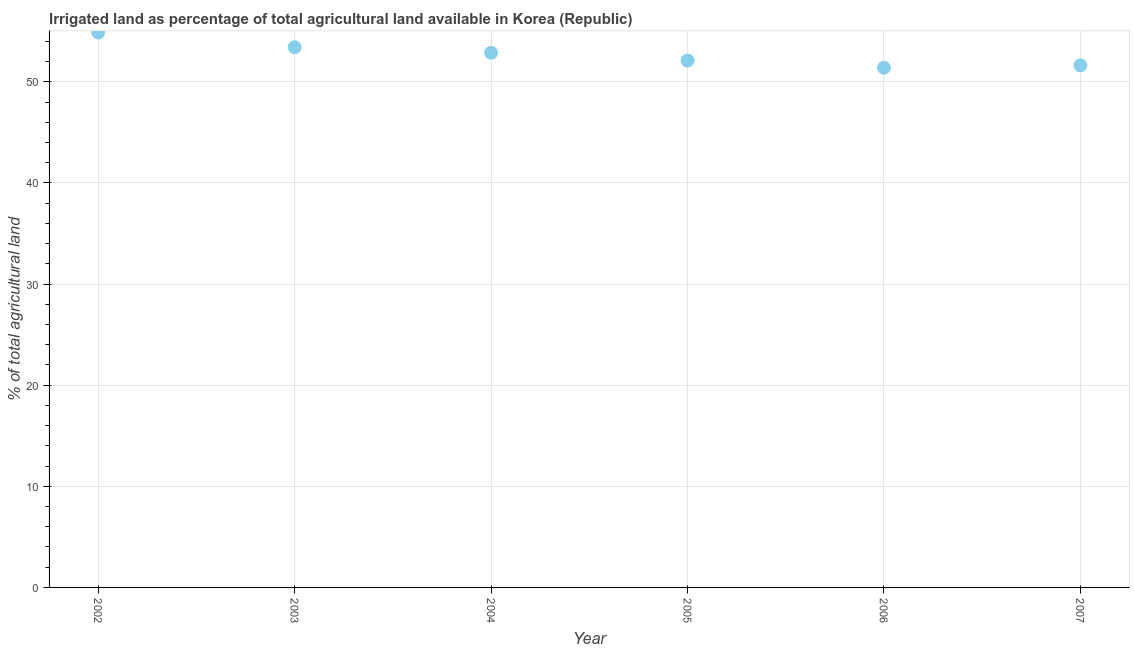What is the percentage of agricultural irrigated land in 2004?
Provide a succinct answer. 52.88. Across all years, what is the maximum percentage of agricultural irrigated land?
Ensure brevity in your answer.  54.87. Across all years, what is the minimum percentage of agricultural irrigated land?
Provide a short and direct response. 51.4. What is the sum of the percentage of agricultural irrigated land?
Make the answer very short. 316.3. What is the difference between the percentage of agricultural irrigated land in 2002 and 2003?
Your answer should be compact. 1.45. What is the average percentage of agricultural irrigated land per year?
Provide a succinct answer. 52.72. What is the median percentage of agricultural irrigated land?
Keep it short and to the point. 52.49. In how many years, is the percentage of agricultural irrigated land greater than 40 %?
Provide a short and direct response. 6. What is the ratio of the percentage of agricultural irrigated land in 2002 to that in 2004?
Offer a very short reply. 1.04. Is the difference between the percentage of agricultural irrigated land in 2005 and 2006 greater than the difference between any two years?
Your response must be concise. No. What is the difference between the highest and the second highest percentage of agricultural irrigated land?
Provide a succinct answer. 1.45. What is the difference between the highest and the lowest percentage of agricultural irrigated land?
Provide a succinct answer. 3.47. Does the percentage of agricultural irrigated land monotonically increase over the years?
Give a very brief answer. No. How many dotlines are there?
Your answer should be very brief. 1. How many years are there in the graph?
Your answer should be compact. 6. What is the difference between two consecutive major ticks on the Y-axis?
Provide a succinct answer. 10. Are the values on the major ticks of Y-axis written in scientific E-notation?
Keep it short and to the point. No. What is the title of the graph?
Make the answer very short. Irrigated land as percentage of total agricultural land available in Korea (Republic). What is the label or title of the Y-axis?
Offer a terse response. % of total agricultural land. What is the % of total agricultural land in 2002?
Provide a succinct answer. 54.87. What is the % of total agricultural land in 2003?
Your answer should be compact. 53.42. What is the % of total agricultural land in 2004?
Provide a succinct answer. 52.88. What is the % of total agricultural land in 2005?
Your answer should be compact. 52.1. What is the % of total agricultural land in 2006?
Give a very brief answer. 51.4. What is the % of total agricultural land in 2007?
Keep it short and to the point. 51.63. What is the difference between the % of total agricultural land in 2002 and 2003?
Offer a terse response. 1.45. What is the difference between the % of total agricultural land in 2002 and 2004?
Give a very brief answer. 1.99. What is the difference between the % of total agricultural land in 2002 and 2005?
Make the answer very short. 2.77. What is the difference between the % of total agricultural land in 2002 and 2006?
Make the answer very short. 3.47. What is the difference between the % of total agricultural land in 2002 and 2007?
Your answer should be very brief. 3.24. What is the difference between the % of total agricultural land in 2003 and 2004?
Ensure brevity in your answer.  0.54. What is the difference between the % of total agricultural land in 2003 and 2005?
Provide a short and direct response. 1.32. What is the difference between the % of total agricultural land in 2003 and 2006?
Keep it short and to the point. 2.02. What is the difference between the % of total agricultural land in 2003 and 2007?
Provide a succinct answer. 1.79. What is the difference between the % of total agricultural land in 2004 and 2005?
Your response must be concise. 0.78. What is the difference between the % of total agricultural land in 2004 and 2006?
Your answer should be very brief. 1.48. What is the difference between the % of total agricultural land in 2004 and 2007?
Provide a short and direct response. 1.25. What is the difference between the % of total agricultural land in 2005 and 2006?
Provide a short and direct response. 0.7. What is the difference between the % of total agricultural land in 2005 and 2007?
Offer a very short reply. 0.47. What is the difference between the % of total agricultural land in 2006 and 2007?
Offer a terse response. -0.23. What is the ratio of the % of total agricultural land in 2002 to that in 2003?
Keep it short and to the point. 1.03. What is the ratio of the % of total agricultural land in 2002 to that in 2004?
Offer a very short reply. 1.04. What is the ratio of the % of total agricultural land in 2002 to that in 2005?
Offer a very short reply. 1.05. What is the ratio of the % of total agricultural land in 2002 to that in 2006?
Offer a terse response. 1.07. What is the ratio of the % of total agricultural land in 2002 to that in 2007?
Your response must be concise. 1.06. What is the ratio of the % of total agricultural land in 2003 to that in 2005?
Your response must be concise. 1.02. What is the ratio of the % of total agricultural land in 2003 to that in 2006?
Your answer should be very brief. 1.04. What is the ratio of the % of total agricultural land in 2003 to that in 2007?
Offer a very short reply. 1.03. What is the ratio of the % of total agricultural land in 2004 to that in 2005?
Make the answer very short. 1.01. What is the ratio of the % of total agricultural land in 2004 to that in 2006?
Provide a succinct answer. 1.03. What is the ratio of the % of total agricultural land in 2006 to that in 2007?
Provide a short and direct response. 1. 